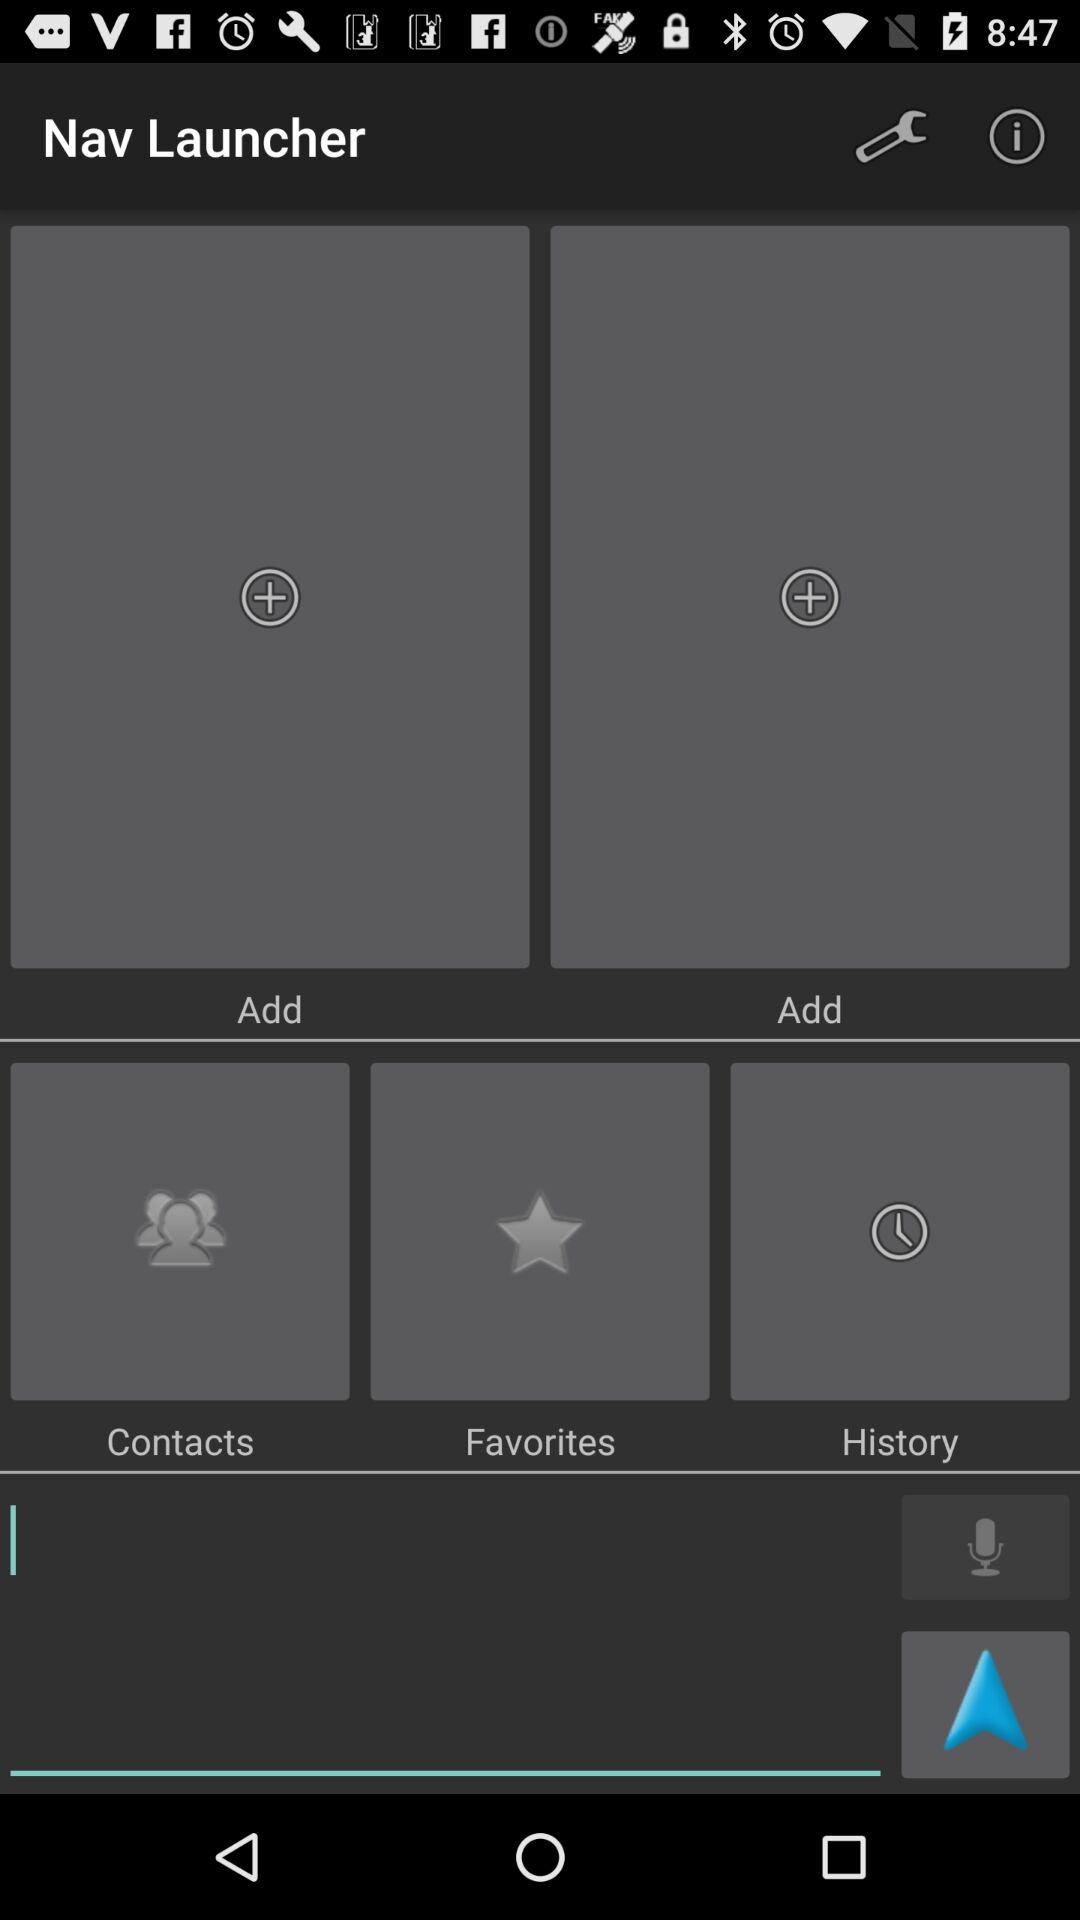What is the application name? The application name is "Nav Launcher". 